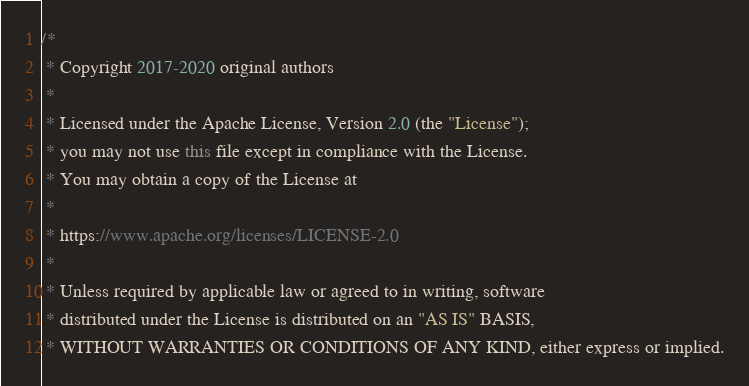Convert code to text. <code><loc_0><loc_0><loc_500><loc_500><_Java_>/*
 * Copyright 2017-2020 original authors
 *
 * Licensed under the Apache License, Version 2.0 (the "License");
 * you may not use this file except in compliance with the License.
 * You may obtain a copy of the License at
 *
 * https://www.apache.org/licenses/LICENSE-2.0
 *
 * Unless required by applicable law or agreed to in writing, software
 * distributed under the License is distributed on an "AS IS" BASIS,
 * WITHOUT WARRANTIES OR CONDITIONS OF ANY KIND, either express or implied.</code> 